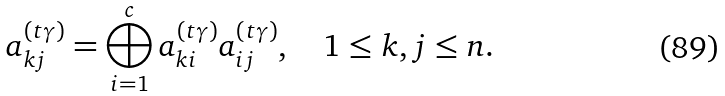<formula> <loc_0><loc_0><loc_500><loc_500>a _ { k j } ^ { ( t \gamma ) } = \bigoplus _ { i = 1 } ^ { c } a _ { k i } ^ { ( t \gamma ) } a _ { i j } ^ { ( t \gamma ) } , \quad 1 \leq k , j \leq n .</formula> 